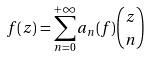Convert formula to latex. <formula><loc_0><loc_0><loc_500><loc_500>f ( z ) = \sum _ { n = 0 } ^ { + \infty } a _ { n } ( f ) \binom { z } { n }</formula> 